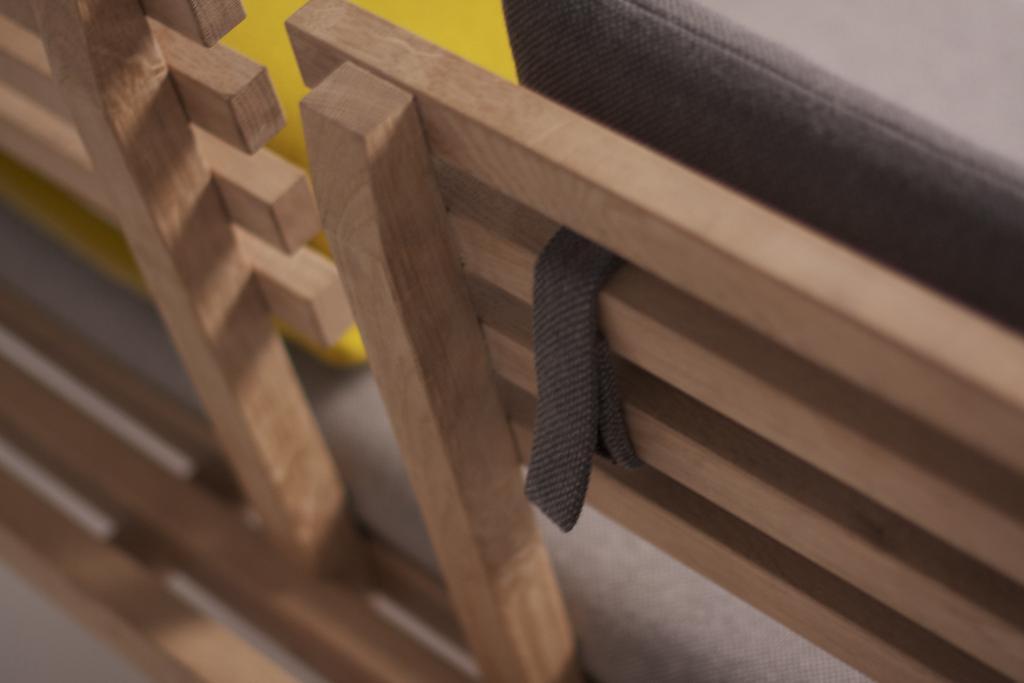Can you describe this image briefly? In this picture, we see the wooden bench. In the right top, we see an object in black color. Beside that, we see an object in yellow color. At the bottom, it is blurred. 